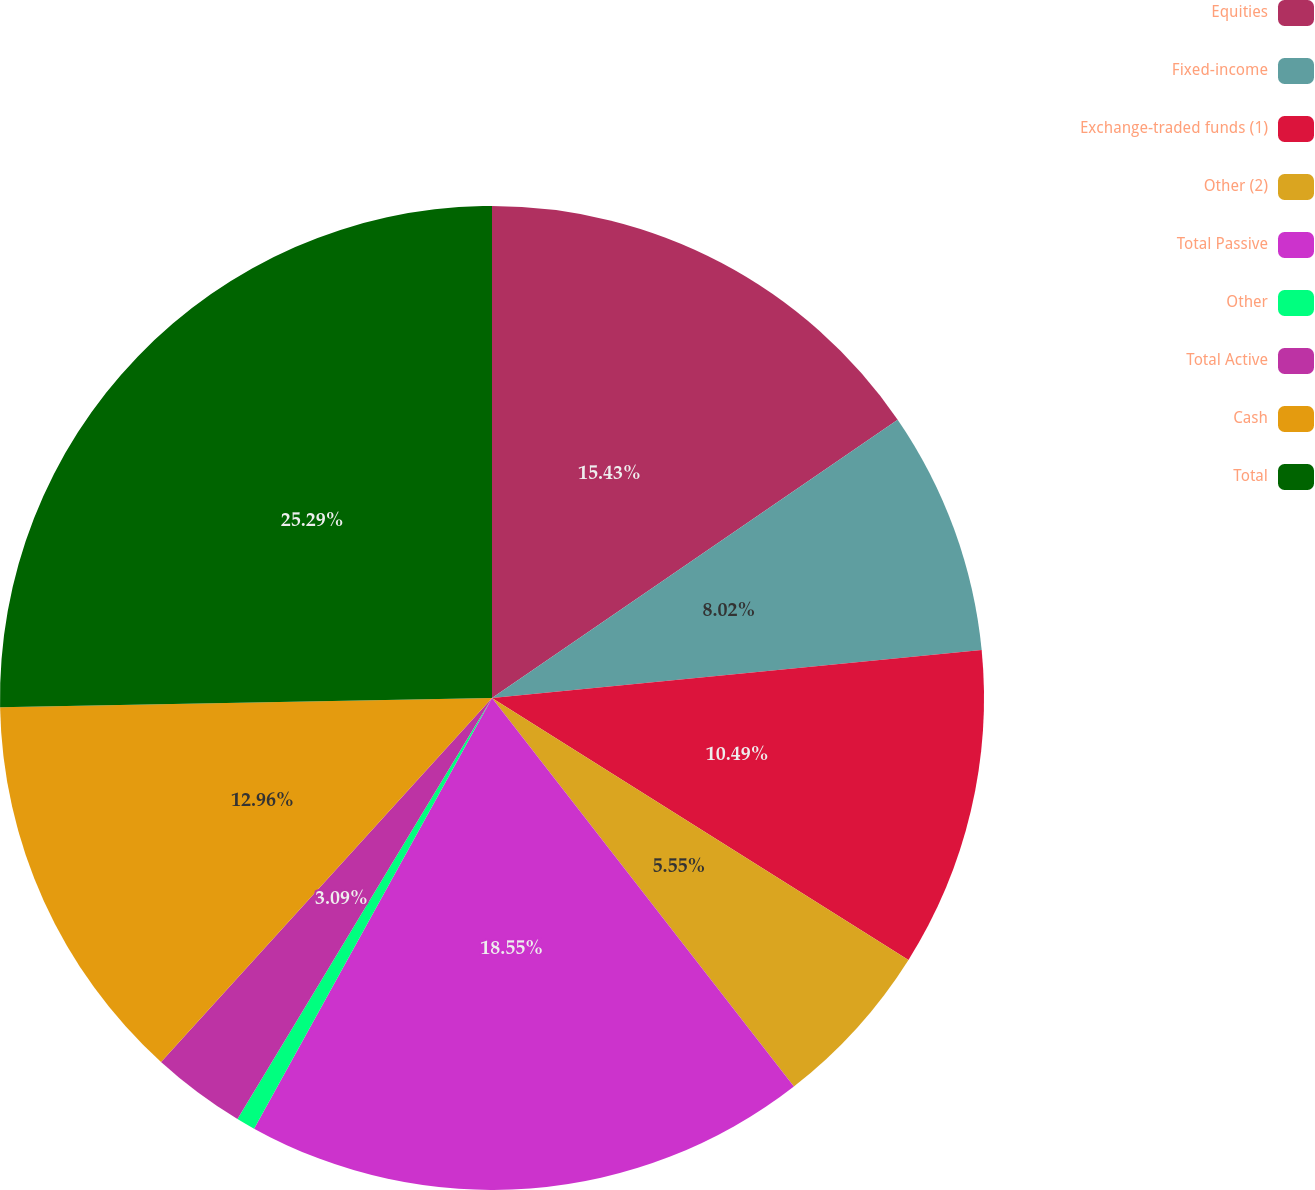<chart> <loc_0><loc_0><loc_500><loc_500><pie_chart><fcel>Equities<fcel>Fixed-income<fcel>Exchange-traded funds (1)<fcel>Other (2)<fcel>Total Passive<fcel>Other<fcel>Total Active<fcel>Cash<fcel>Total<nl><fcel>15.43%<fcel>8.02%<fcel>10.49%<fcel>5.55%<fcel>18.55%<fcel>0.62%<fcel>3.09%<fcel>12.96%<fcel>25.3%<nl></chart> 